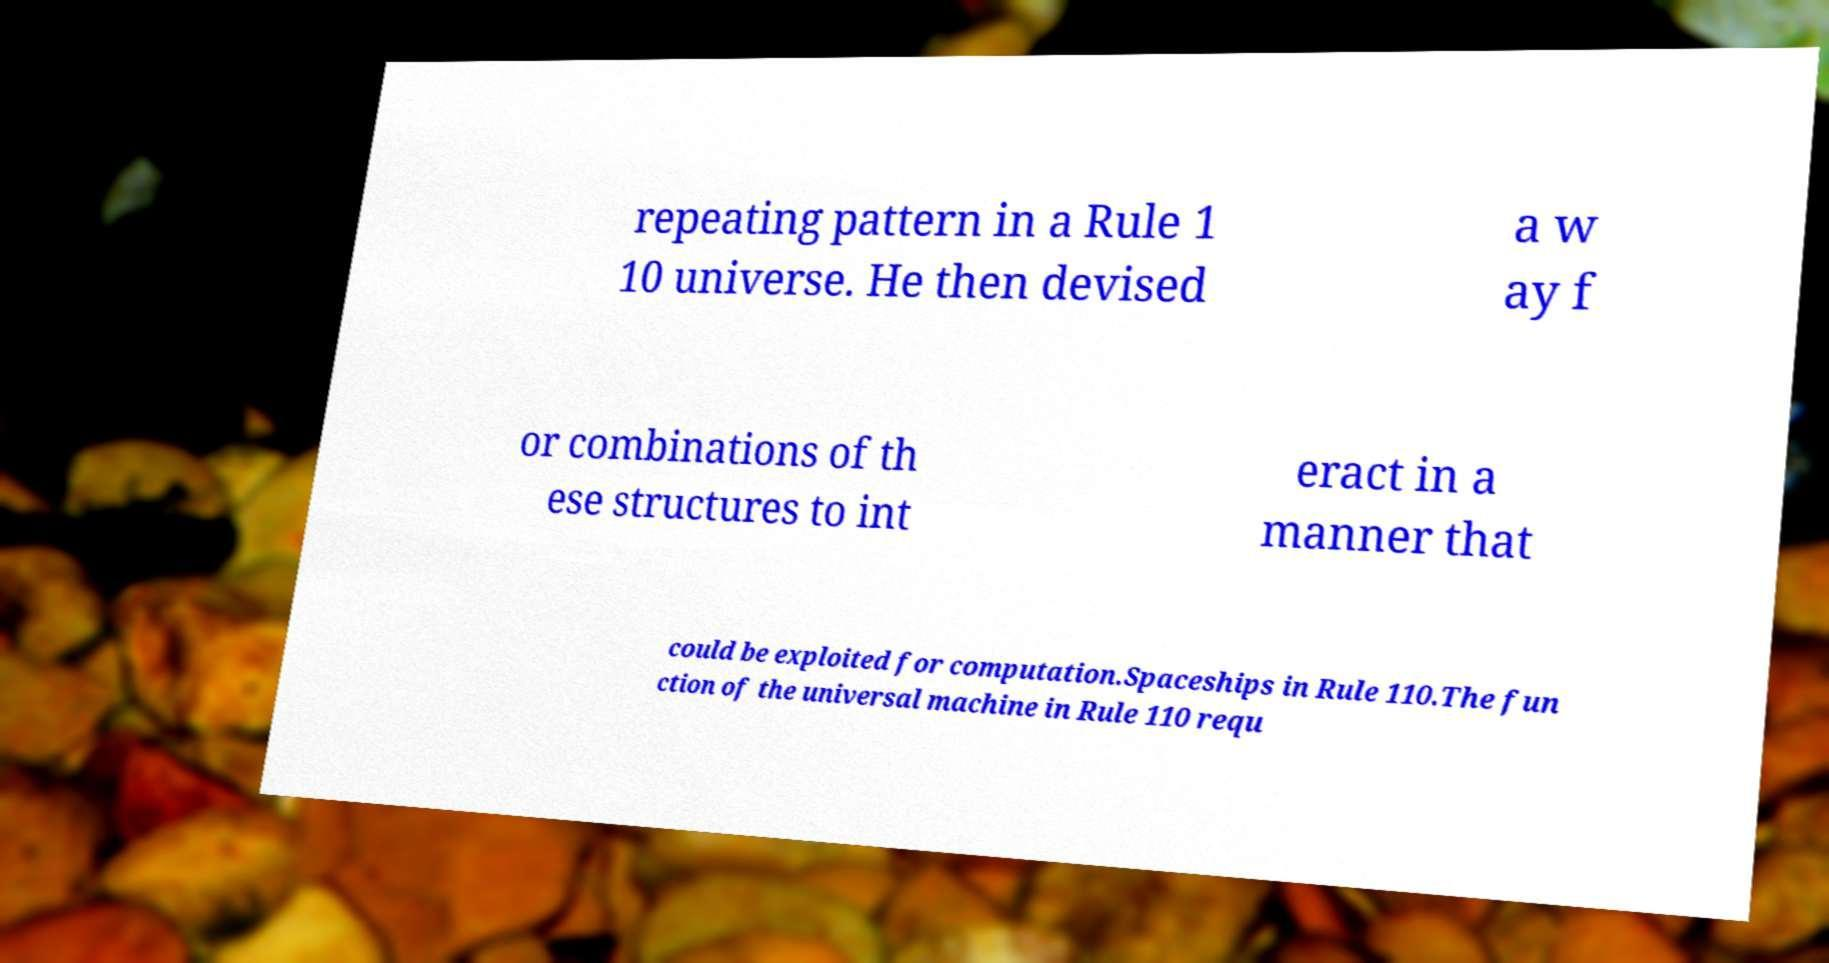Could you extract and type out the text from this image? repeating pattern in a Rule 1 10 universe. He then devised a w ay f or combinations of th ese structures to int eract in a manner that could be exploited for computation.Spaceships in Rule 110.The fun ction of the universal machine in Rule 110 requ 